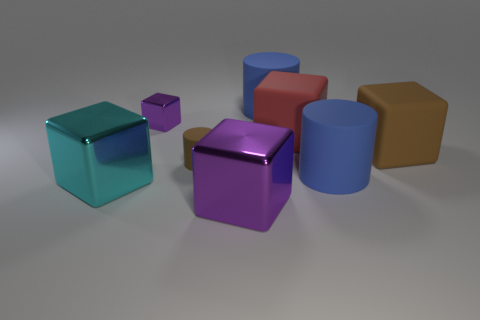How many big rubber cubes are the same color as the small rubber cylinder?
Ensure brevity in your answer.  1. Do the big cyan metal thing and the purple metallic thing in front of the red rubber object have the same shape?
Offer a terse response. Yes. There is another purple metallic object that is the same shape as the large purple shiny thing; what size is it?
Ensure brevity in your answer.  Small. How many other things are made of the same material as the red object?
Keep it short and to the point. 4. What material is the cyan cube?
Provide a succinct answer. Metal. There is a shiny block behind the red rubber object; does it have the same color as the big metallic object on the right side of the small shiny thing?
Your answer should be very brief. Yes. Is the number of purple metallic blocks that are to the right of the red matte cube greater than the number of purple spheres?
Give a very brief answer. No. How many other things are the same color as the small block?
Ensure brevity in your answer.  1. Do the purple cube that is behind the cyan shiny block and the large cyan cube have the same size?
Offer a very short reply. No. Is there a purple shiny block of the same size as the red object?
Make the answer very short. Yes. 